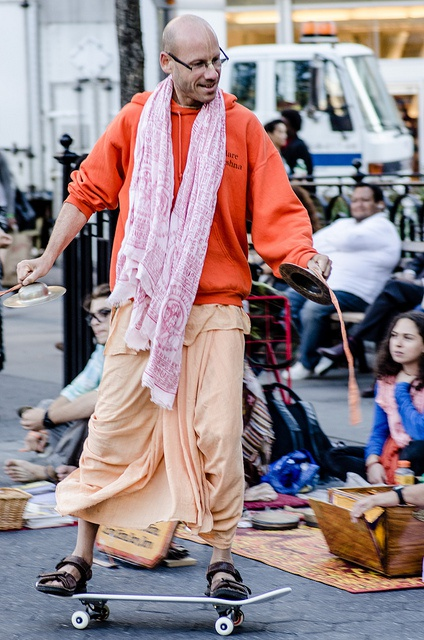Describe the objects in this image and their specific colors. I can see people in lightgray, lavender, lightpink, salmon, and pink tones, truck in lightgray, darkgray, and gray tones, people in lightgray, lavender, black, and darkgray tones, people in lightgray, black, darkgray, blue, and pink tones, and people in lightgray, darkgray, gray, and black tones in this image. 